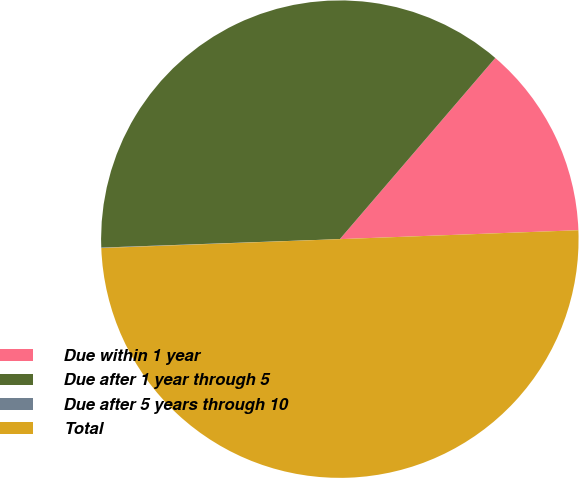Convert chart to OTSL. <chart><loc_0><loc_0><loc_500><loc_500><pie_chart><fcel>Due within 1 year<fcel>Due after 1 year through 5<fcel>Due after 5 years through 10<fcel>Total<nl><fcel>13.12%<fcel>36.85%<fcel>0.03%<fcel>50.0%<nl></chart> 